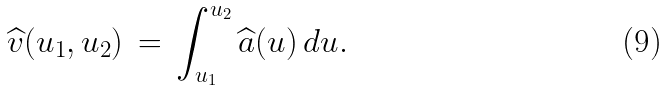<formula> <loc_0><loc_0><loc_500><loc_500>\widehat { v } ( u _ { 1 } , u _ { 2 } ) \, = \, \int _ { u _ { 1 } } ^ { u _ { 2 } } \widehat { a } ( u ) \, d u .</formula> 